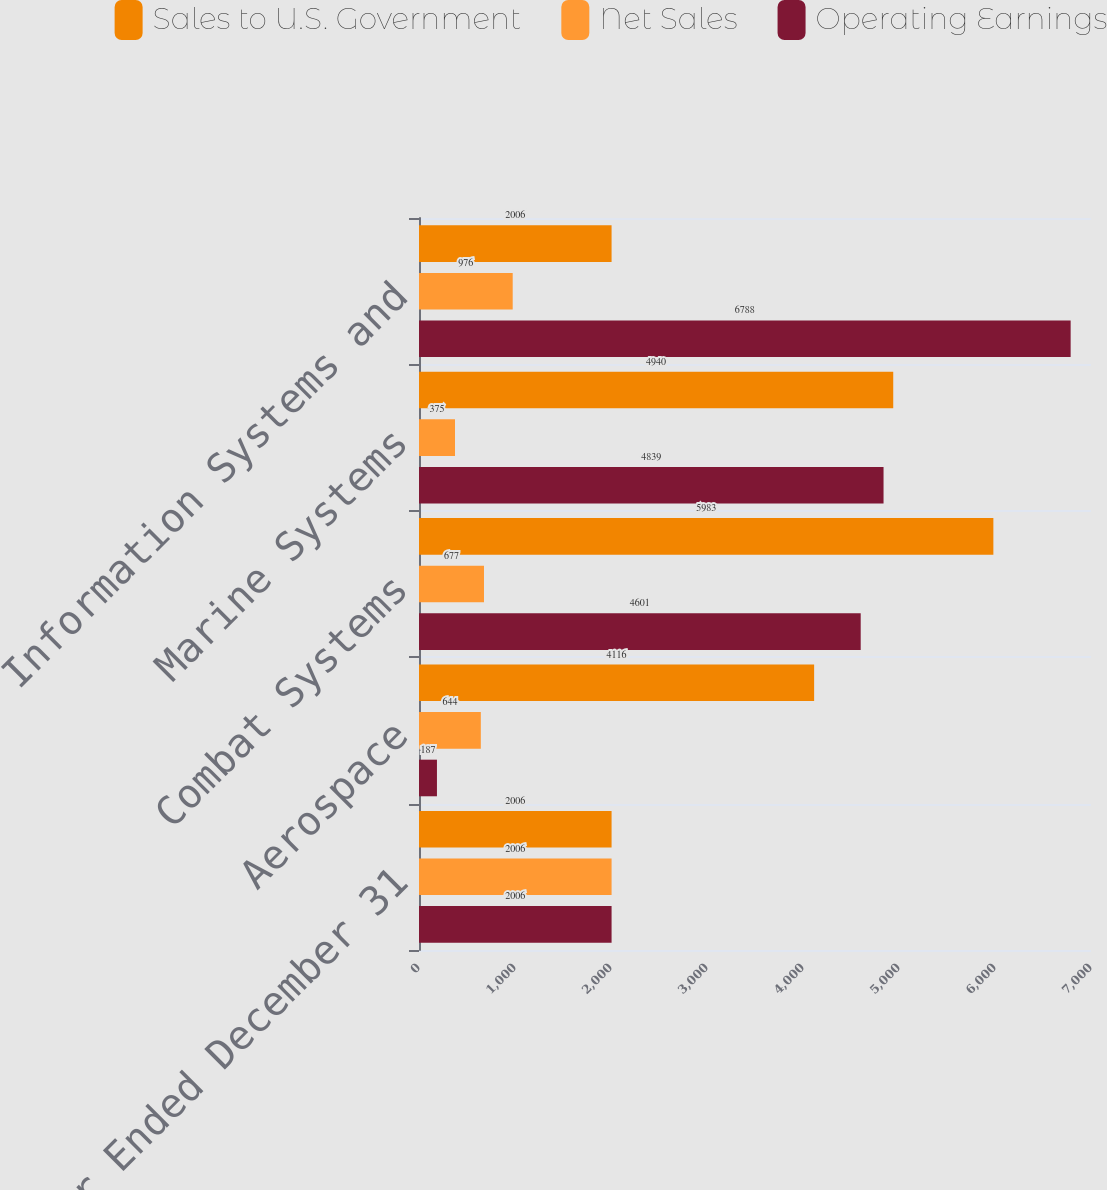Convert chart to OTSL. <chart><loc_0><loc_0><loc_500><loc_500><stacked_bar_chart><ecel><fcel>Year Ended December 31<fcel>Aerospace<fcel>Combat Systems<fcel>Marine Systems<fcel>Information Systems and<nl><fcel>Sales to U.S. Government<fcel>2006<fcel>4116<fcel>5983<fcel>4940<fcel>2006<nl><fcel>Net Sales<fcel>2006<fcel>644<fcel>677<fcel>375<fcel>976<nl><fcel>Operating Earnings<fcel>2006<fcel>187<fcel>4601<fcel>4839<fcel>6788<nl></chart> 